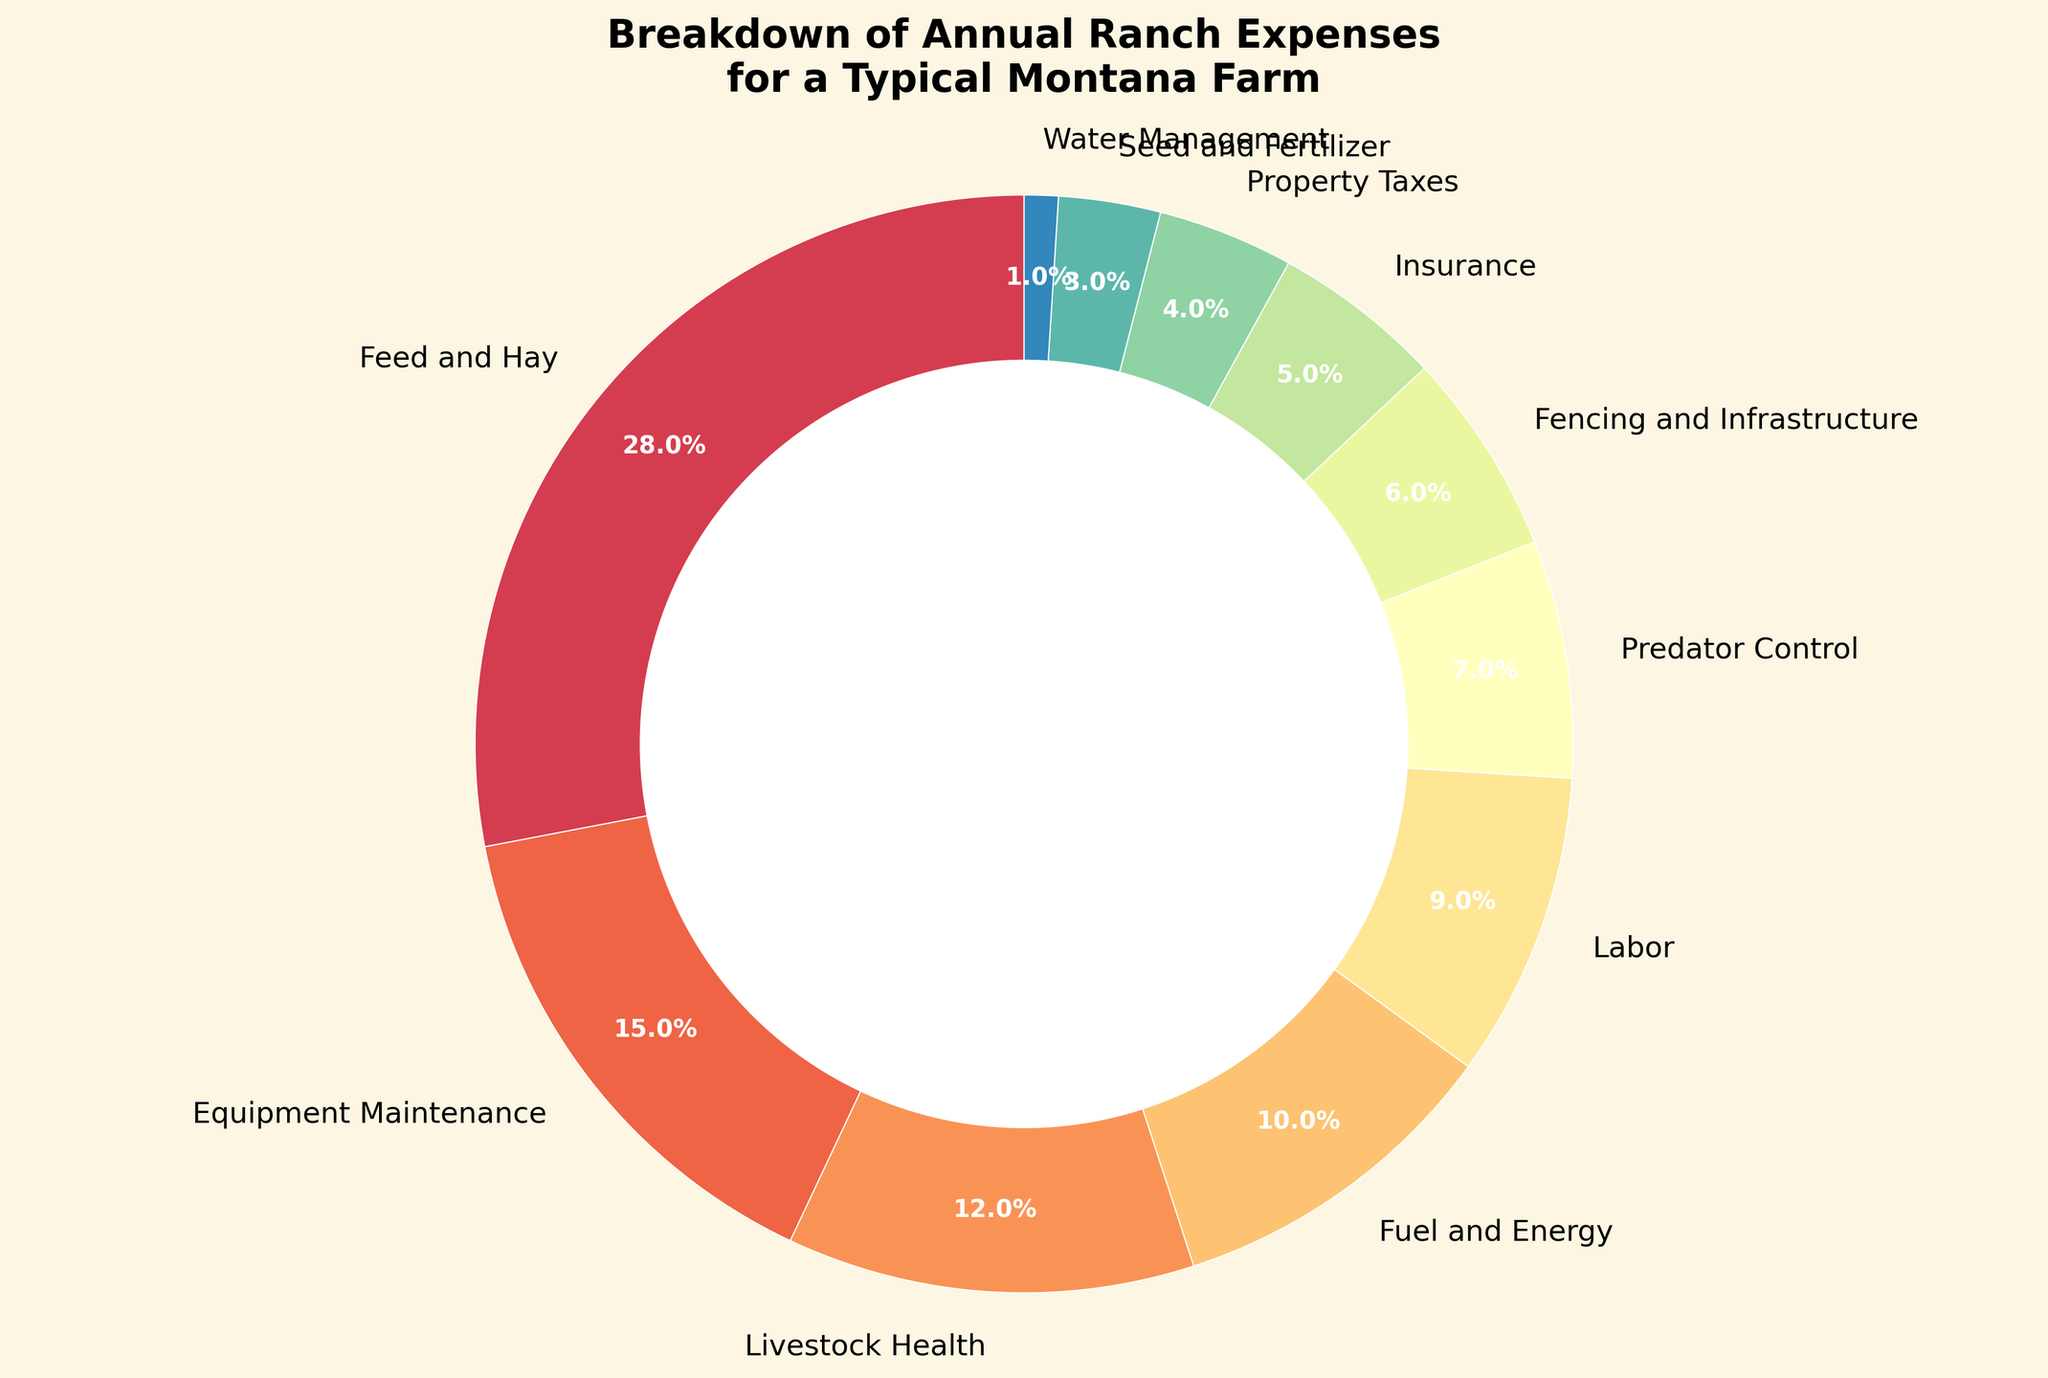Which category has the highest percentage of annual ranch expenses? Look at the pie chart and identify the largest wedge slice by percentage. This slice represents the "Feed and Hay" category with 28%.
Answer: Feed and Hay What is the combined percentage of expenses for "Equipment Maintenance" and "Livestock Health"? Add the percentages of "Equipment Maintenance" (15%) and "Livestock Health" (12%). The combined percentage is 15% + 12% = 27%.
Answer: 27% Which category is smaller in percentage: "Labor" or "Predator Control"? Compare the slices for "Labor" and "Predator Control". "Labor" is 9%, while "Predator Control" is 7%. Therefore, "Predator Control" is smaller.
Answer: Predator Control What is the total percentage for all categories listed in the pie chart? Sum all the given percentages: 28% + 15% + 12% + 10% + 9% + 7% + 6% + 5% + 4% + 3% + 1%. The total percentage is 100%.
Answer: 100% Which category has the smallest slice, and what is its percentage? Find the smallest slice in the pie chart which corresponds to "Water Management" with 1%.
Answer: Water Management What is the difference in percentage between "Fuel and Energy" and "Property Taxes"? Subtract the percentage of "Property Taxes" (4%) from "Fuel and Energy" (10%). The difference is 10% - 4% = 6%.
Answer: 6% How much more is spent on "Feed and Hay" compared to "Seed and Fertilizer"? Subtract the percentage of "Seed and Fertilizer" (3%) from "Feed and Hay" (28%). The difference is 28% - 3% = 25%.
Answer: 25% Which category represents a higher expense, "Insurance" or "Fencing and Infrastructure"? Compare the slices for "Insurance" and "Fencing and Infrastructure". "Insurance" is 5% and "Fencing and Infrastructure" is 6%. Therefore, "Fencing and Infrastructure" is higher.
Answer: Fencing and Infrastructure Calculate the average percentage of categories that are below 10%. Identify categories below 10% (Labor - 9%, Predator Control - 7%, Fencing and Infrastructure - 6%, Insurance - 5%, Property Taxes - 4%, Seed and Fertilizer - 3%, Water Management - 1%), then sum their percentages and divide by number of categories. The sum is 9+7+6+5+4+3+1 = 35, divided by 7 categories. The average is 35 / 7 = 5%.
Answer: 5% If you combine "Fencing and Infrastructure" and "Insurance", what would be the new combined percentage, and where would it rank compared to other categories? Add the percentages of "Fencing and Infrastructure" (6%) and "Insurance" (5%). The combined percentage is 6% + 5% = 11%. This new category, at 11%, would be ranked fourth, after "Feed and Hay" (28%), "Equipment Maintenance" (15%), and "Livestock Health" (12%).
Answer: 11%, fourth 